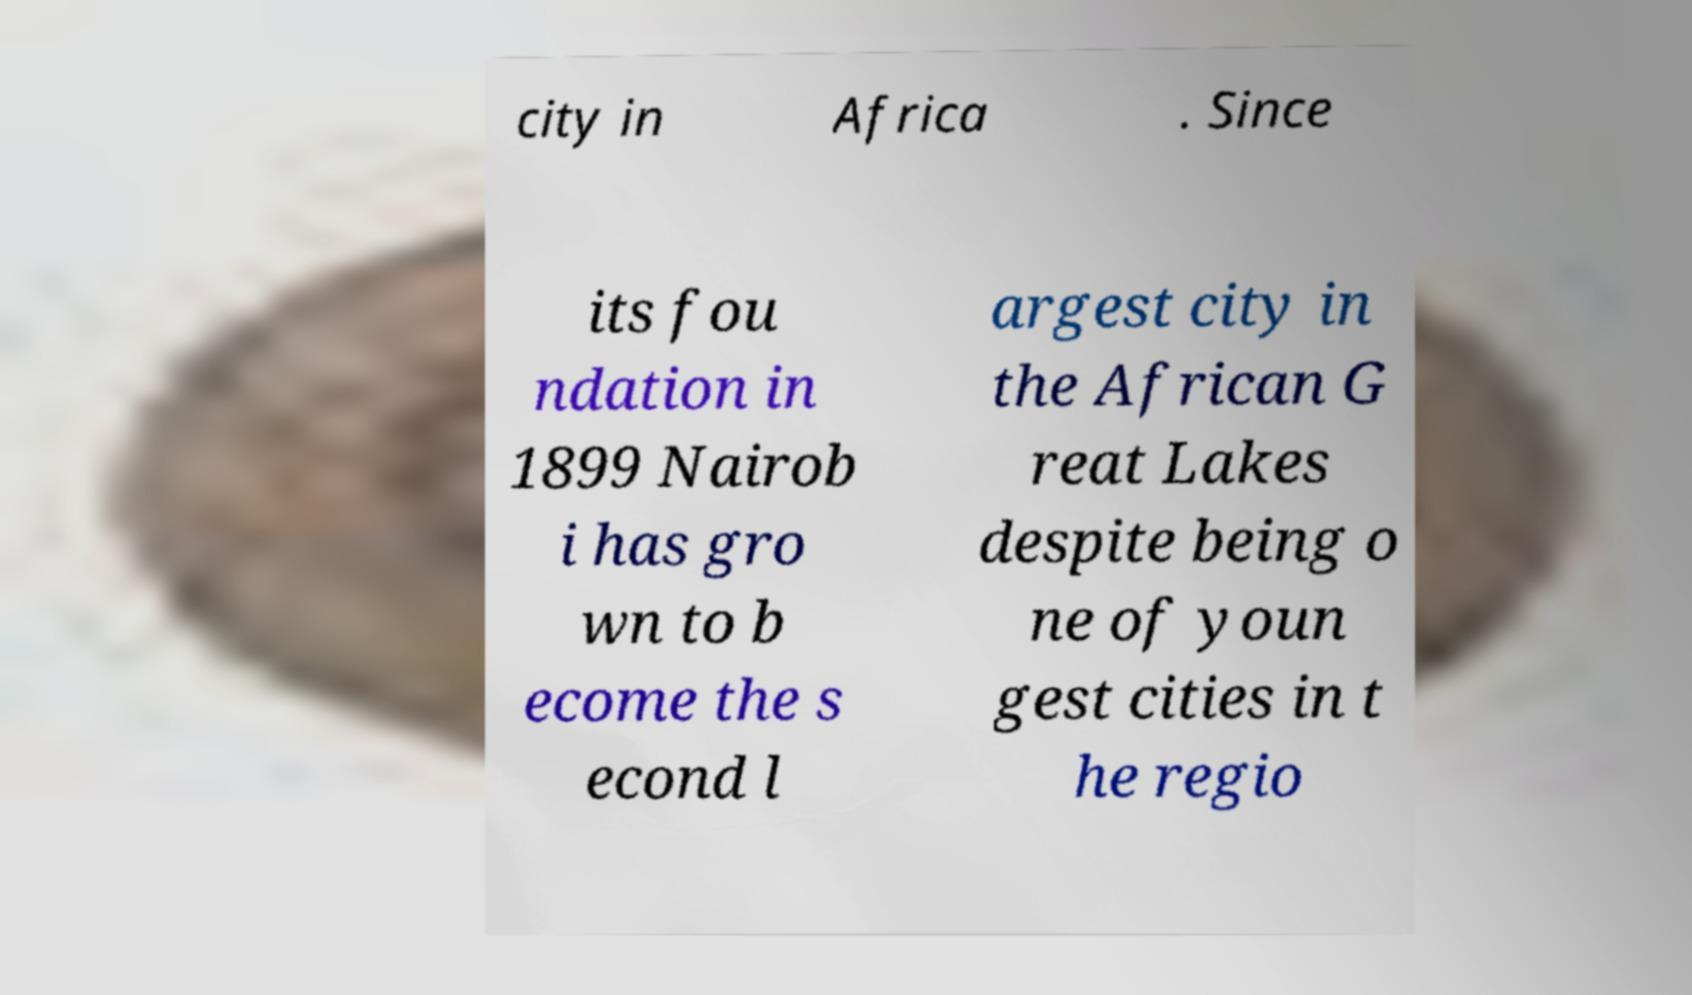Can you accurately transcribe the text from the provided image for me? city in Africa . Since its fou ndation in 1899 Nairob i has gro wn to b ecome the s econd l argest city in the African G reat Lakes despite being o ne of youn gest cities in t he regio 